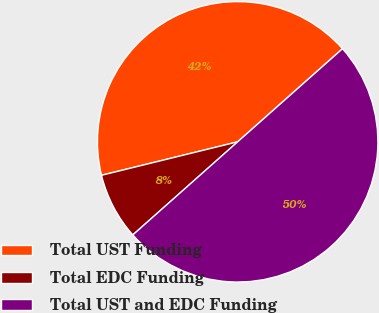<chart> <loc_0><loc_0><loc_500><loc_500><pie_chart><fcel>Total UST Funding<fcel>Total EDC Funding<fcel>Total UST and EDC Funding<nl><fcel>42.28%<fcel>7.72%<fcel>50.0%<nl></chart> 